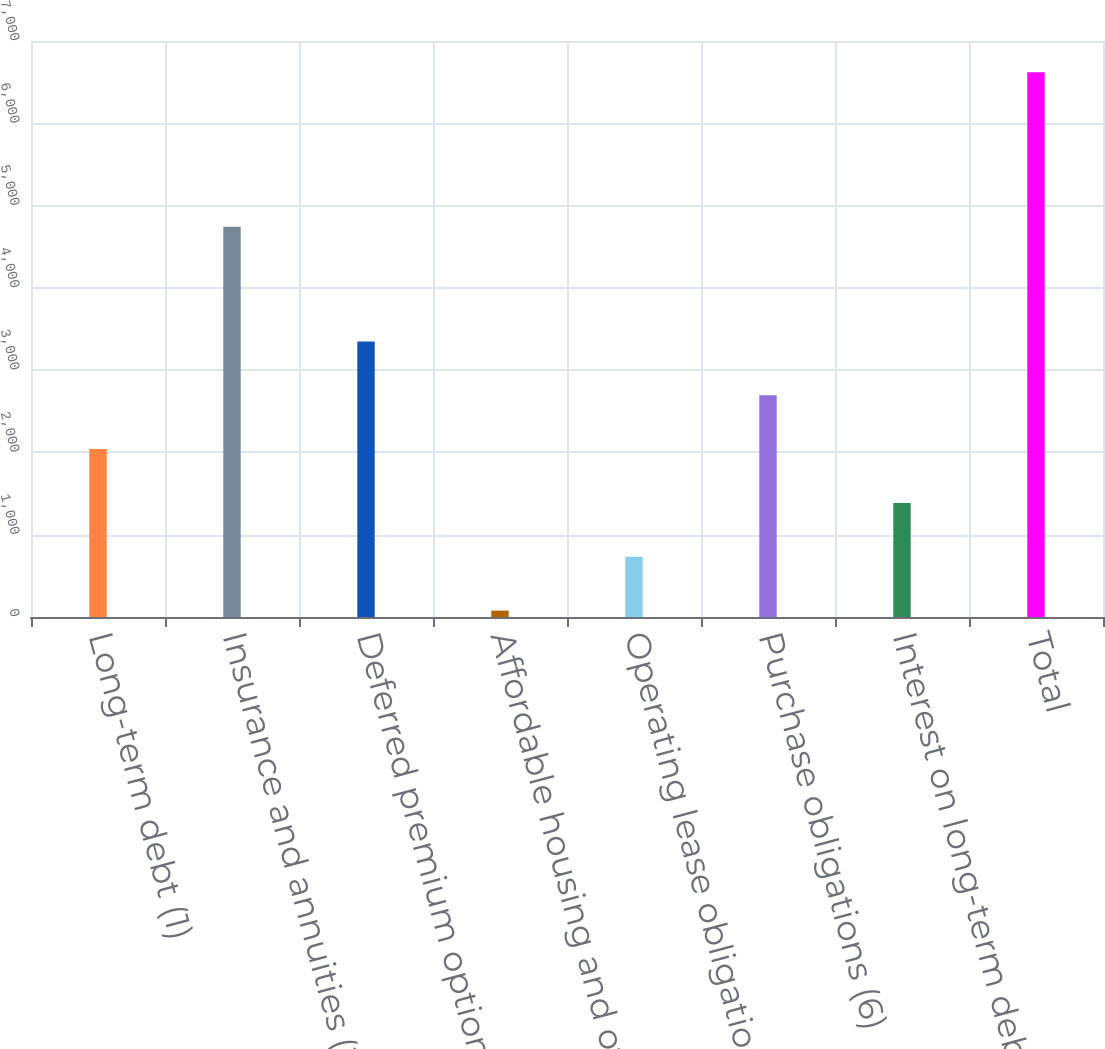Convert chart to OTSL. <chart><loc_0><loc_0><loc_500><loc_500><bar_chart><fcel>Long-term debt (1)<fcel>Insurance and annuities (2)<fcel>Deferred premium options (4)<fcel>Affordable housing and other<fcel>Operating lease obligations<fcel>Purchase obligations (6)<fcel>Interest on long-term debt (7)<fcel>Total<nl><fcel>2040.6<fcel>4743<fcel>3349<fcel>78<fcel>732.2<fcel>2694.8<fcel>1386.4<fcel>6620<nl></chart> 